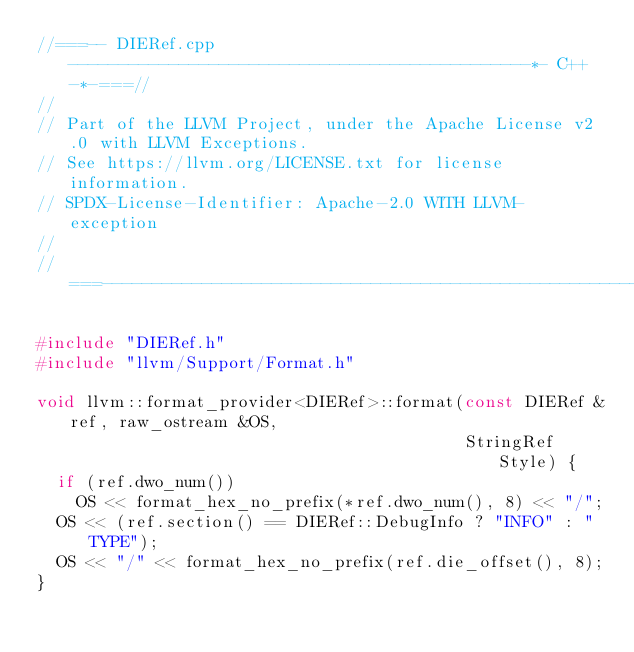Convert code to text. <code><loc_0><loc_0><loc_500><loc_500><_C++_>//===-- DIERef.cpp ----------------------------------------------*- C++ -*-===//
//
// Part of the LLVM Project, under the Apache License v2.0 with LLVM Exceptions.
// See https://llvm.org/LICENSE.txt for license information.
// SPDX-License-Identifier: Apache-2.0 WITH LLVM-exception
//
//===----------------------------------------------------------------------===//

#include "DIERef.h"
#include "llvm/Support/Format.h"

void llvm::format_provider<DIERef>::format(const DIERef &ref, raw_ostream &OS,
                                           StringRef Style) {
  if (ref.dwo_num())
    OS << format_hex_no_prefix(*ref.dwo_num(), 8) << "/";
  OS << (ref.section() == DIERef::DebugInfo ? "INFO" : "TYPE");
  OS << "/" << format_hex_no_prefix(ref.die_offset(), 8);
}
</code> 